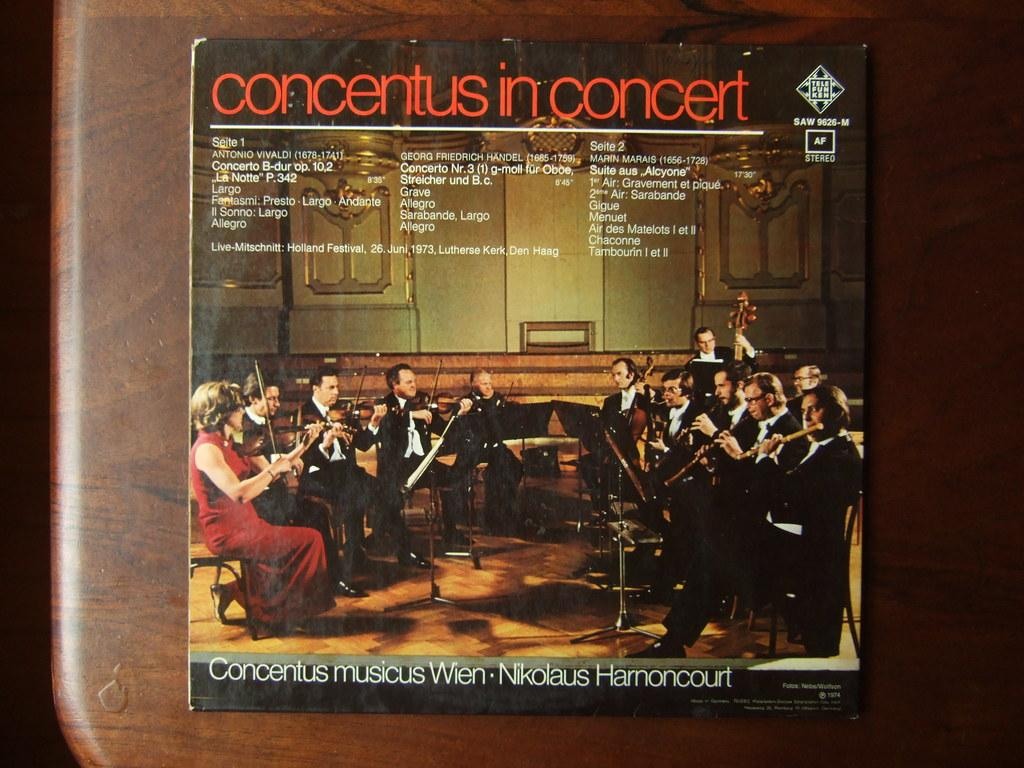Provide a one-sentence caption for the provided image. A record album of Concertus in Concert showing men and women playing instruments on the cover. 